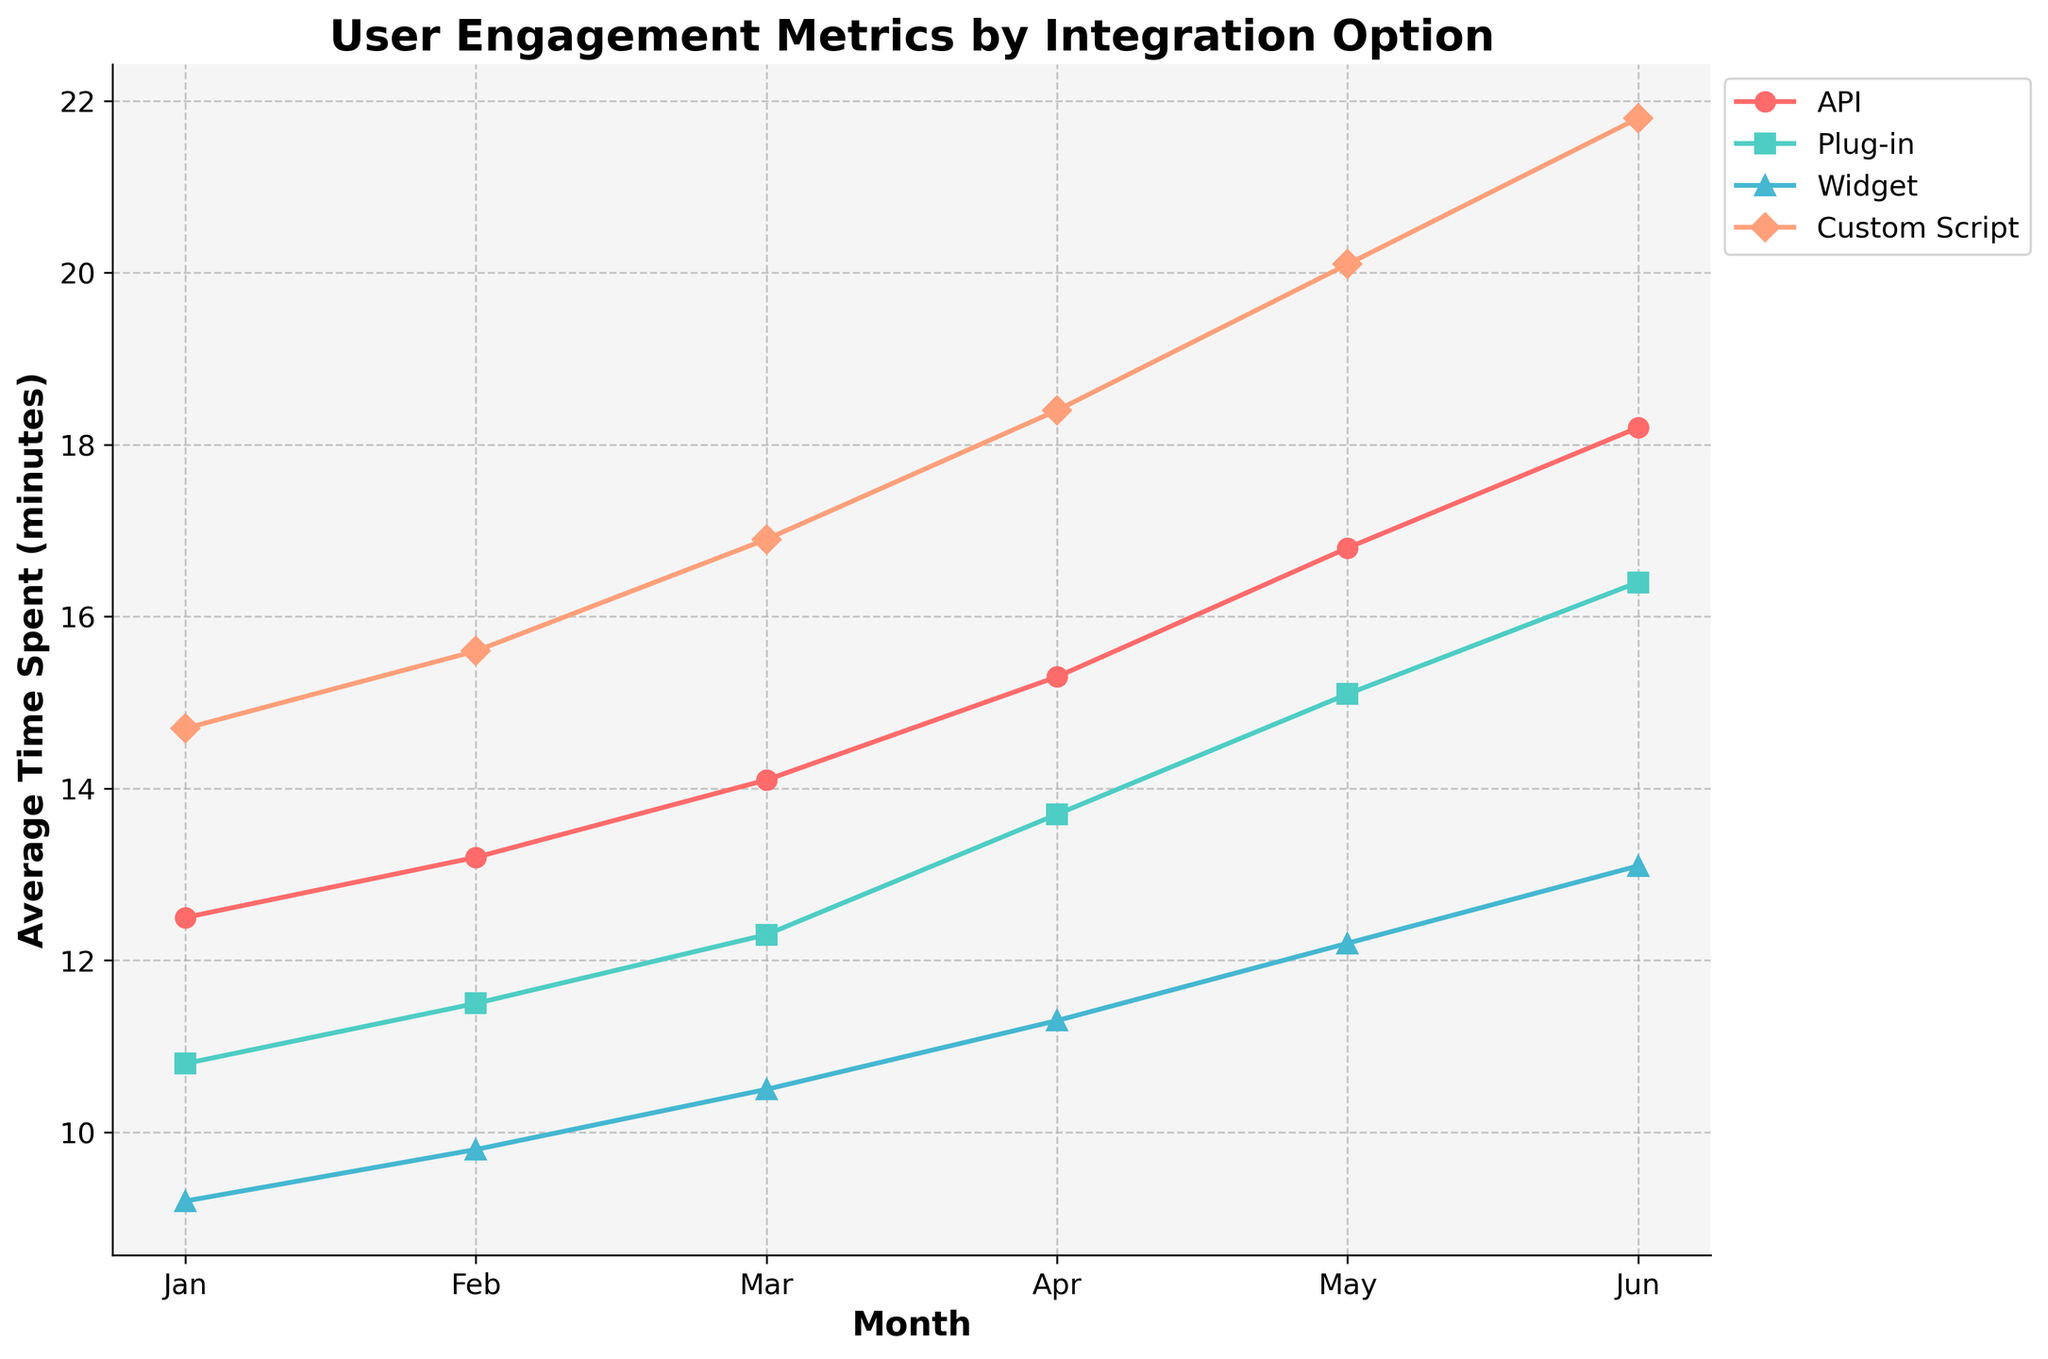What month did the API integration option have the highest average time spent? The API integration option's average time spent increases each month, so the highest value will be during the last month represented in the data. This is June, with 18.2 minutes.
Answer: June Which integration option had the highest average pages visited in May? In May, we can see from the figure that the Custom Script integration option has the highest average pages visited, indicated by the highest point on the graph for that month.
Answer: Custom Script Is the trend for average time spent increasing or decreasing for the Widget integration option from January to June? The average time spent for the Widget integration option shows an increasing trend from January (9.2 minutes) up to June (13.1 minutes).
Answer: Increasing What is the difference in average time spent between the Custom Script and Plug-in integration options in March? In March, the average time spent for Custom Script is 16.9 minutes, and for Plug-in it is 12.3 minutes. The difference is 16.9 - 12.3 = 4.6 minutes.
Answer: 4.6 minutes Which integration option had the most significant increase in average pages visited between April and May? Comparing the average pages visited from April to May for each integration option, Custom Script shows the largest increase (from 13 to 14 = 1).
Answer: Custom Script How does the average time spent for the API integration option in February compare to that of the Plug-in option in the same month? In February, the average time spent for the API option is 13.2 minutes, while for the Plug-in option it is 11.5 minutes. Therefore, the API option has a higher average time spent.
Answer: API is higher What is the average time spent in June for all integration options combined? Adding the average time spent for each option in June: API (18.2) + Plug-in (16.4) + Widget (13.1) + Custom Script (21.8). The total is 69.5 minutes, and the average is 69.5 / 4 = 17.375 minutes.
Answer: 17.375 minutes Which integration option showed the slowest increase in average pages visited over the six months? The Widget integration option shows the slowest increase in average pages visited, starting from 6 in January and reaching 11 in June (an increase of 5 pages).
Answer: Widget Between which two consecutive months did the API integration option see the largest increase in average time spent? Looking at the average time spent each month for the API integration option, the largest increase is between May (16.8 minutes) and June (18.2 minutes), which is an increase of 1.4 minutes.
Answer: May to June How many more pages did users visit on average in June compared to January for the Plug-in integration option? In June, users visited an average of 12 pages with the Plug-in integration option, and in January, they visited 7 pages. The difference is 12 - 7 = 5 pages.
Answer: 5 pages 